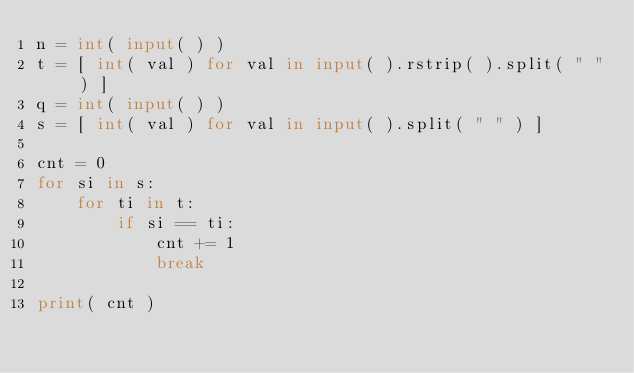Convert code to text. <code><loc_0><loc_0><loc_500><loc_500><_Python_>n = int( input( ) )
t = [ int( val ) for val in input( ).rstrip( ).split( " " ) ]
q = int( input( ) )
s = [ int( val ) for val in input( ).split( " " ) ]

cnt = 0
for si in s:
	for ti in t:
		if si == ti:
			cnt += 1
			break

print( cnt )</code> 